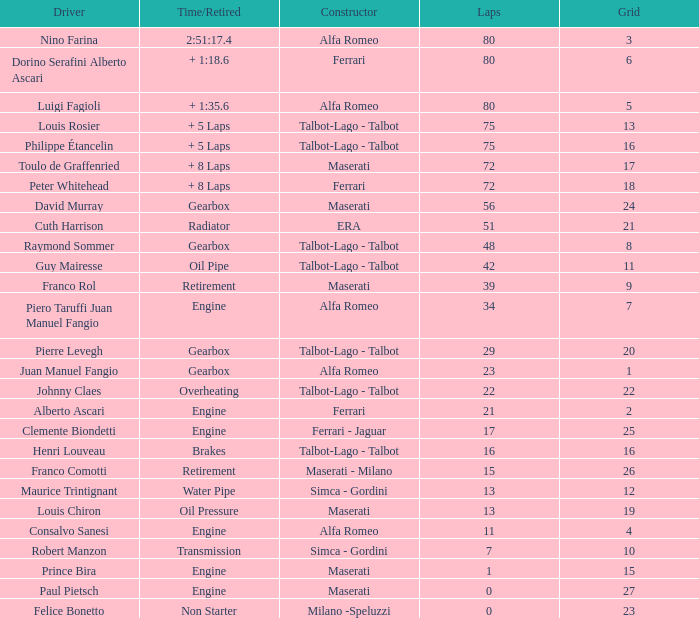When grid is less than 7, laps are greater than 17, and time/retired is + 1:35.6, who is the constructor? Alfa Romeo. 